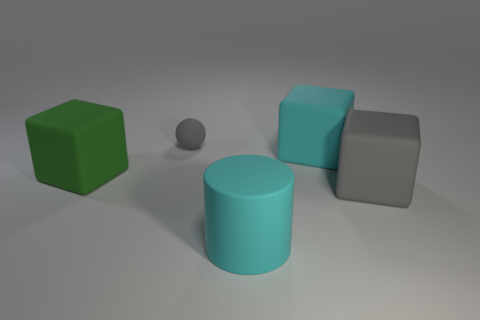What material is the big thing that is the same color as the tiny sphere?
Your response must be concise. Rubber. There is a small sphere; is its color the same as the big rubber cube that is in front of the green rubber object?
Your answer should be very brief. Yes. What number of green cubes are in front of the small rubber thing?
Ensure brevity in your answer.  1. Is there another green thing that has the same material as the small object?
Offer a very short reply. Yes. There is a gray cube that is the same size as the cyan block; what is it made of?
Ensure brevity in your answer.  Rubber. There is a rubber thing that is both on the right side of the green cube and left of the big cyan cylinder; what size is it?
Ensure brevity in your answer.  Small. What is the color of the thing that is both behind the large green rubber block and right of the gray rubber ball?
Make the answer very short. Cyan. Are there fewer gray balls that are on the left side of the big cyan matte cylinder than blocks to the right of the ball?
Offer a very short reply. Yes. What number of large cyan matte objects have the same shape as the big green rubber thing?
Your response must be concise. 1. What size is the gray cube that is made of the same material as the cyan block?
Give a very brief answer. Large. 